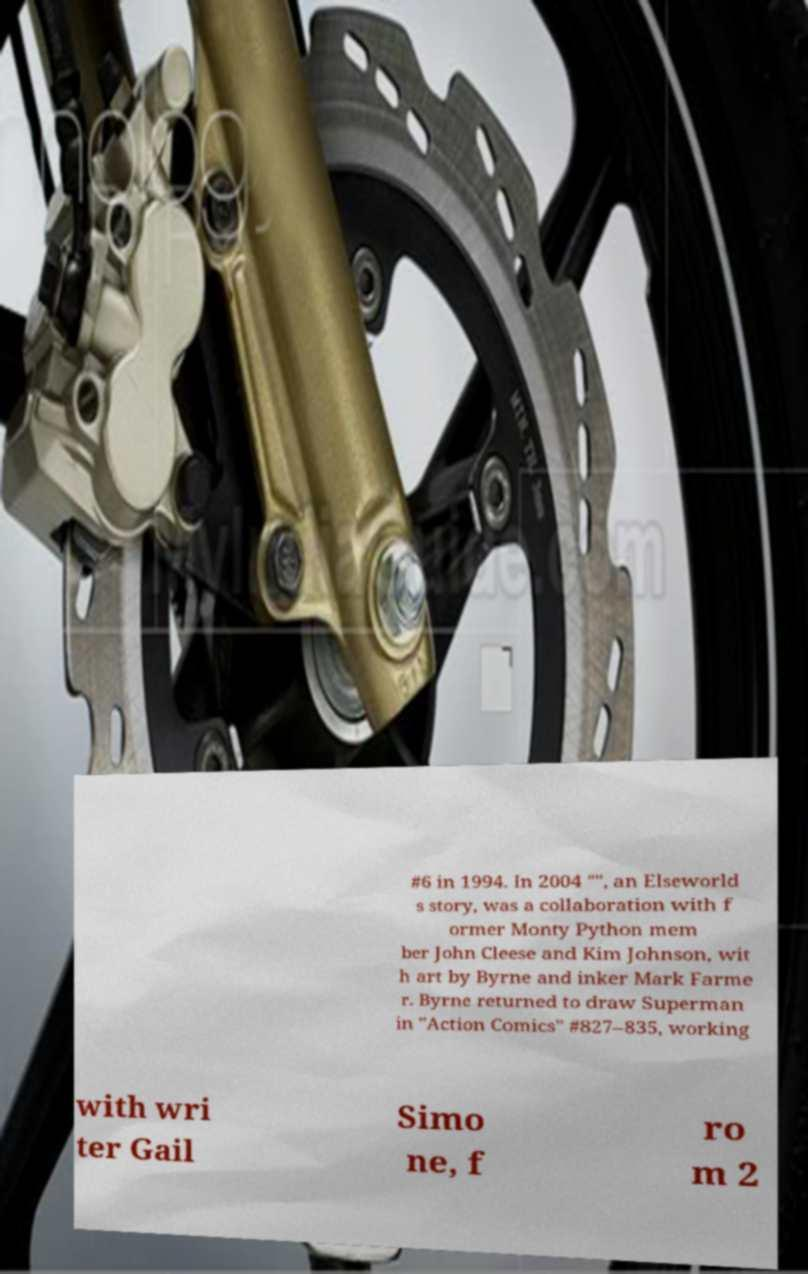Can you accurately transcribe the text from the provided image for me? #6 in 1994. In 2004 "", an Elseworld s story, was a collaboration with f ormer Monty Python mem ber John Cleese and Kim Johnson, wit h art by Byrne and inker Mark Farme r. Byrne returned to draw Superman in "Action Comics" #827–835, working with wri ter Gail Simo ne, f ro m 2 